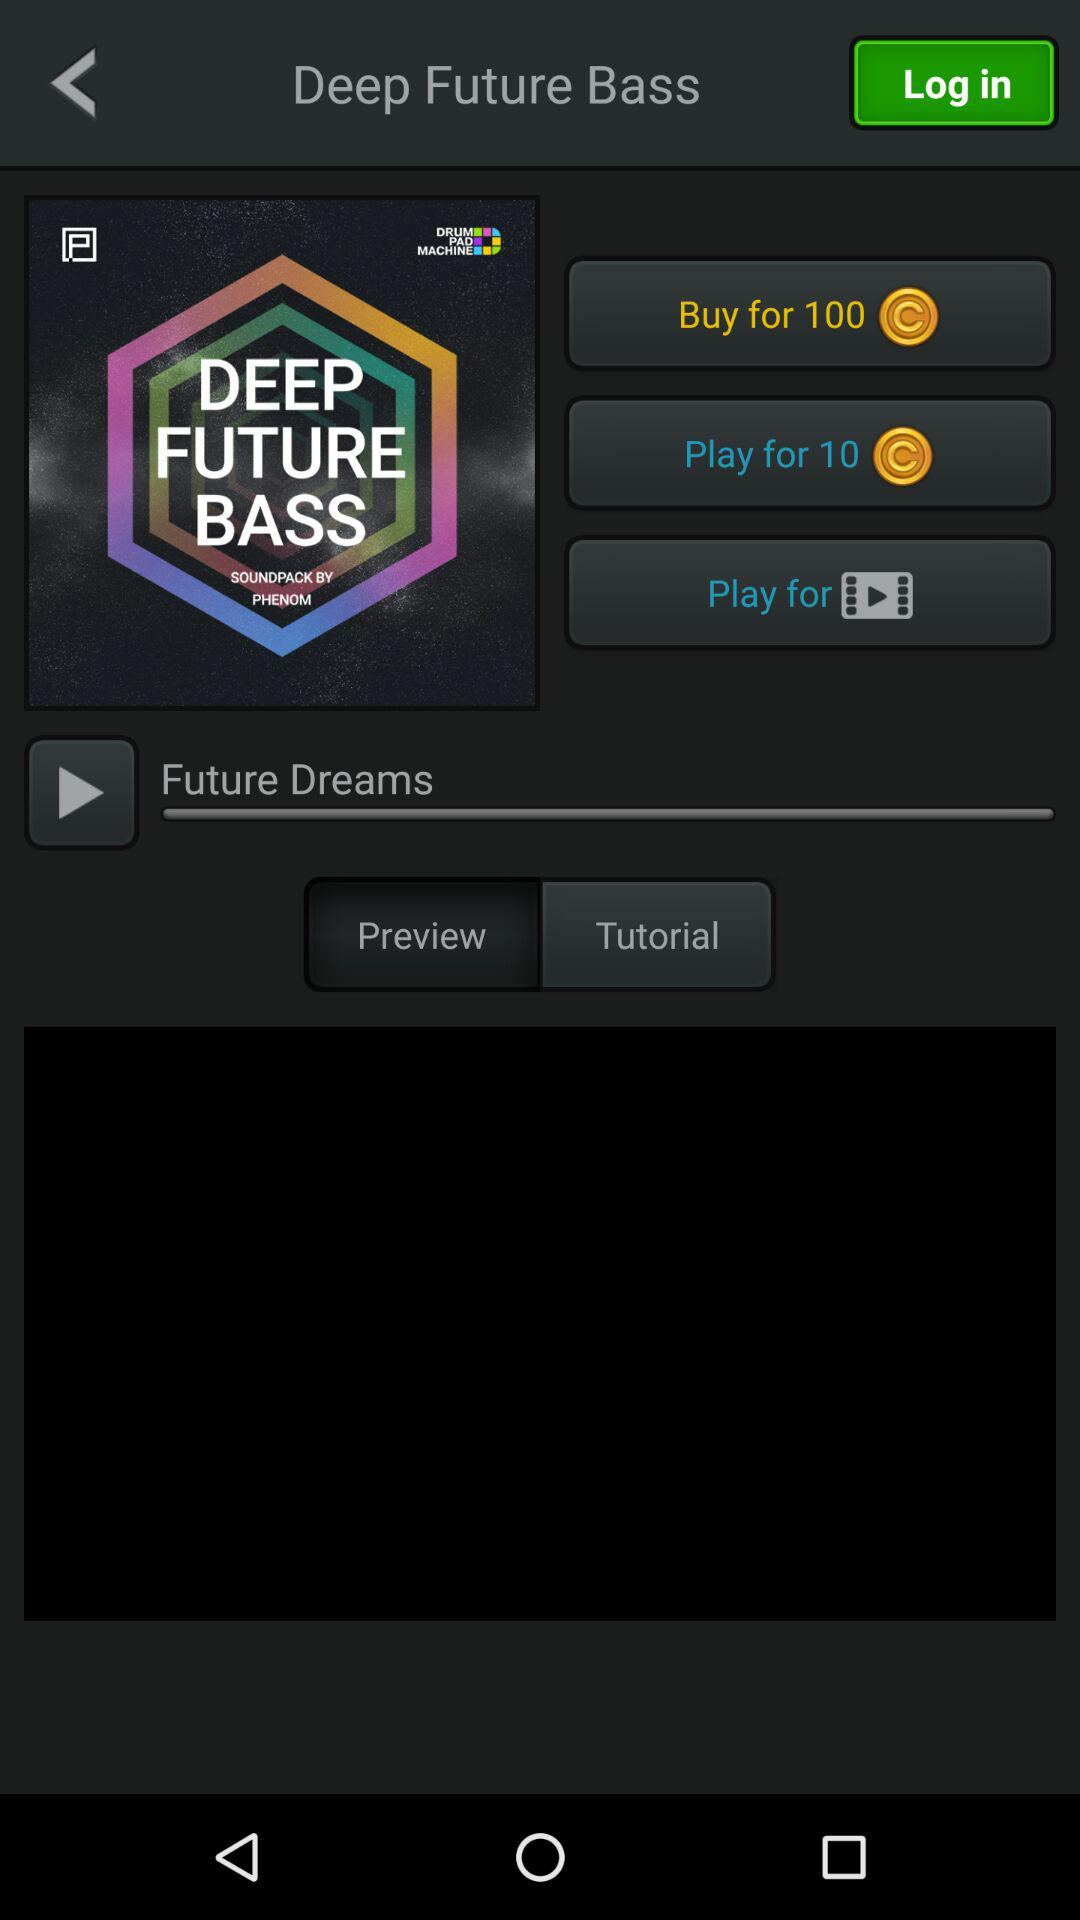How much more does it cost to buy the song than to play it?
Answer the question using a single word or phrase. 90 